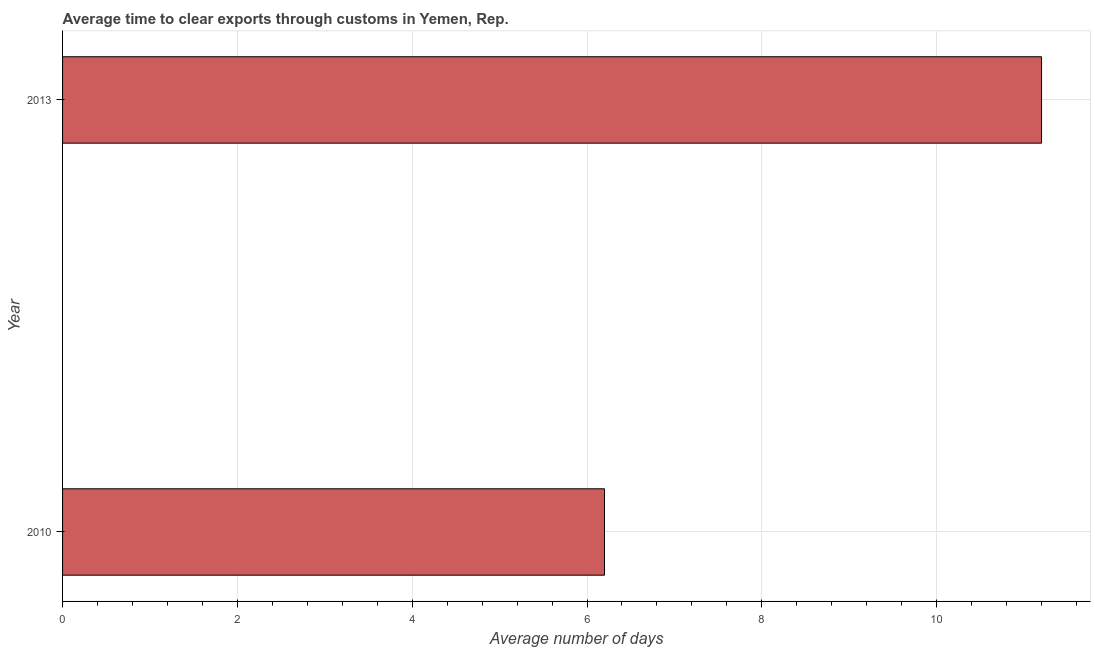Does the graph contain any zero values?
Offer a very short reply. No. What is the title of the graph?
Offer a very short reply. Average time to clear exports through customs in Yemen, Rep. What is the label or title of the X-axis?
Provide a succinct answer. Average number of days. Across all years, what is the maximum time to clear exports through customs?
Ensure brevity in your answer.  11.2. Across all years, what is the minimum time to clear exports through customs?
Your answer should be very brief. 6.2. In which year was the time to clear exports through customs minimum?
Your answer should be compact. 2010. What is the sum of the time to clear exports through customs?
Offer a terse response. 17.4. What is the difference between the time to clear exports through customs in 2010 and 2013?
Provide a short and direct response. -5. What is the average time to clear exports through customs per year?
Your answer should be very brief. 8.7. What is the median time to clear exports through customs?
Make the answer very short. 8.7. In how many years, is the time to clear exports through customs greater than 1.2 days?
Offer a very short reply. 2. What is the ratio of the time to clear exports through customs in 2010 to that in 2013?
Your answer should be compact. 0.55. Is the time to clear exports through customs in 2010 less than that in 2013?
Provide a succinct answer. Yes. In how many years, is the time to clear exports through customs greater than the average time to clear exports through customs taken over all years?
Ensure brevity in your answer.  1. Are all the bars in the graph horizontal?
Ensure brevity in your answer.  Yes. What is the difference between two consecutive major ticks on the X-axis?
Offer a very short reply. 2. What is the Average number of days in 2010?
Your answer should be very brief. 6.2. What is the Average number of days in 2013?
Give a very brief answer. 11.2. What is the difference between the Average number of days in 2010 and 2013?
Give a very brief answer. -5. What is the ratio of the Average number of days in 2010 to that in 2013?
Keep it short and to the point. 0.55. 